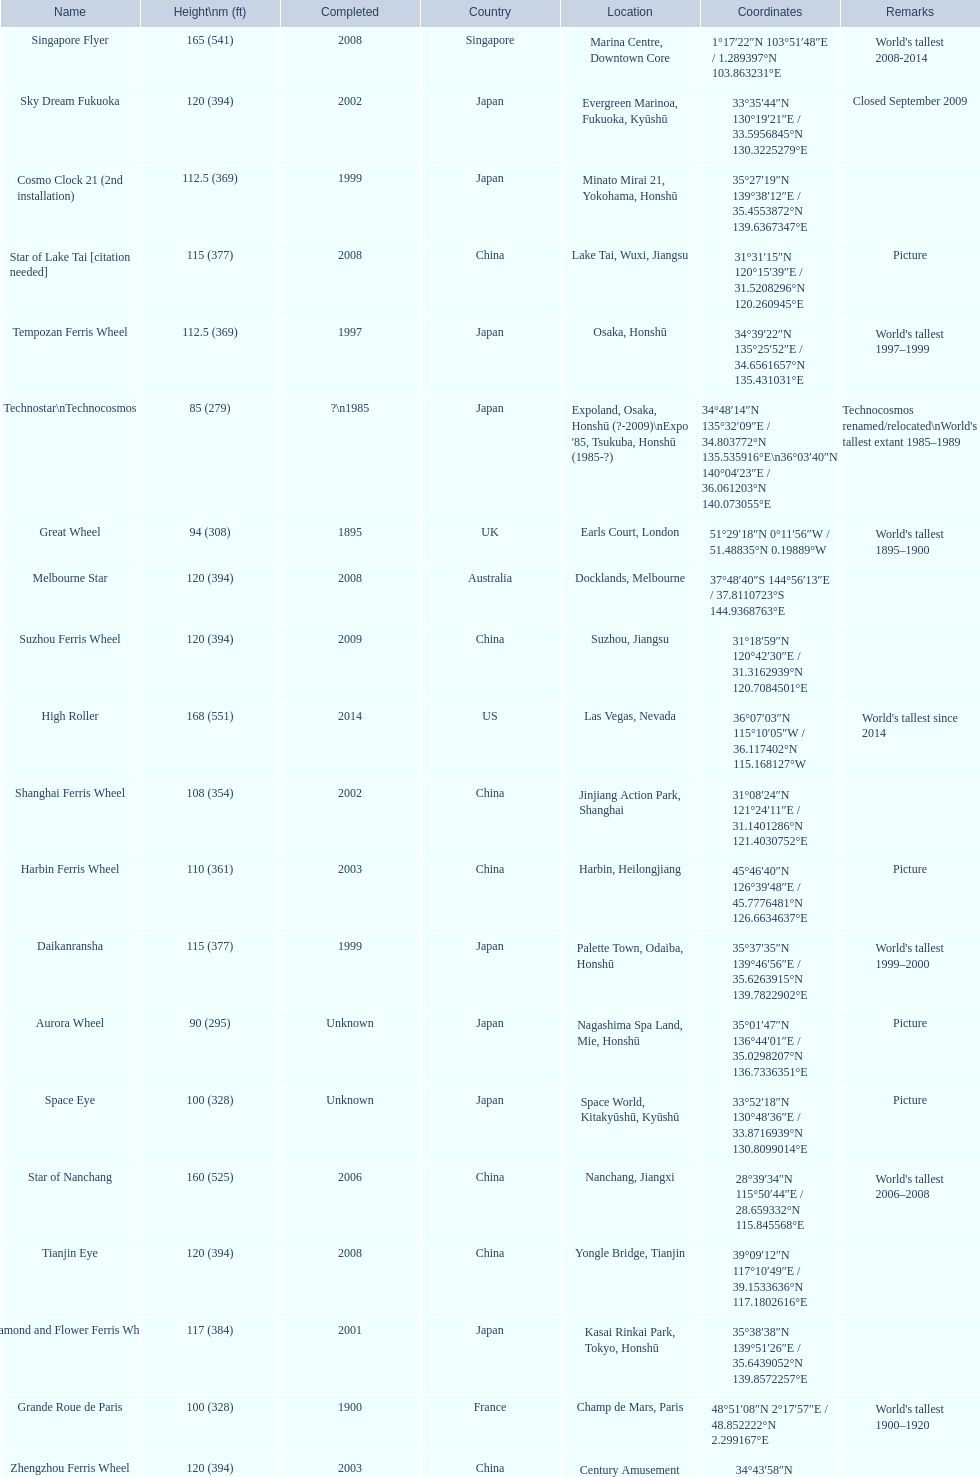Which of the following roller coasters is the oldest: star of lake tai, star of nanchang, melbourne star Star of Nanchang. 